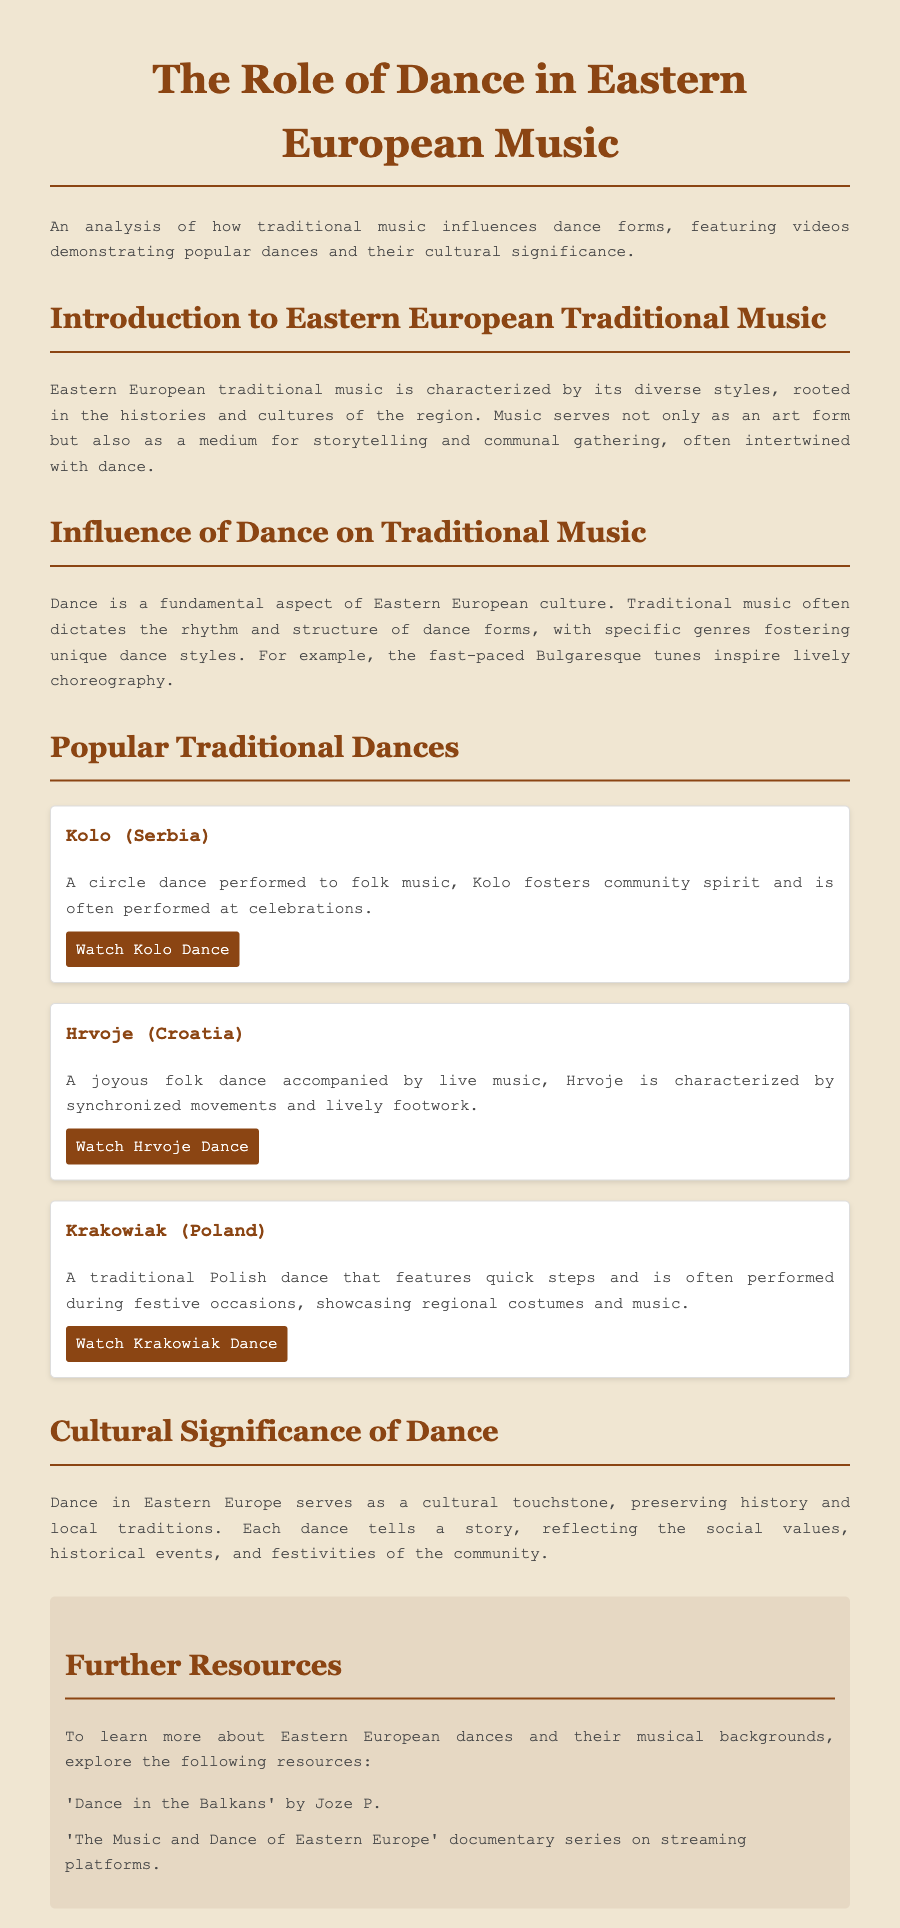What is the title of the document? The title of the document is found in the title section, which prominently displays it.
Answer: The Role of Dance in Eastern European Music What is the first dance mentioned in the document? The first dance mentioned is typically listed in the section discussing popular traditional dances.
Answer: Kolo (Serbia) How is Kolo described? The description of Kolo can be found in its respective dance card in the document.
Answer: A circle dance performed to folk music What does Hrvoje characterize? Hrvoje is characterized by specific features mentioned in its dance card.
Answer: Synchronized movements and lively footwork How many popular traditional dances are highlighted? The number of dances highlighted can be counted in the section dedicated to popular traditional dances.
Answer: Three What does dance serve as in Eastern Europe? The document mentions the cultural role of dance in a specific section discussing its significance.
Answer: A cultural touchstone What type of resources is mentioned for further learning? The types of resources for further learning are listed in the resources section of the document.
Answer: Books and documentary series What is the main theme of the document? The main theme can be understood through the overarching title and introductory paragraph discussing its focus.
Answer: The influence of traditional music on dance forms How does the document describe the influence of traditional music? The influence of traditional music is explained within a specific paragraph regarding dance.
Answer: Dictates the rhythm and structure of dance forms 